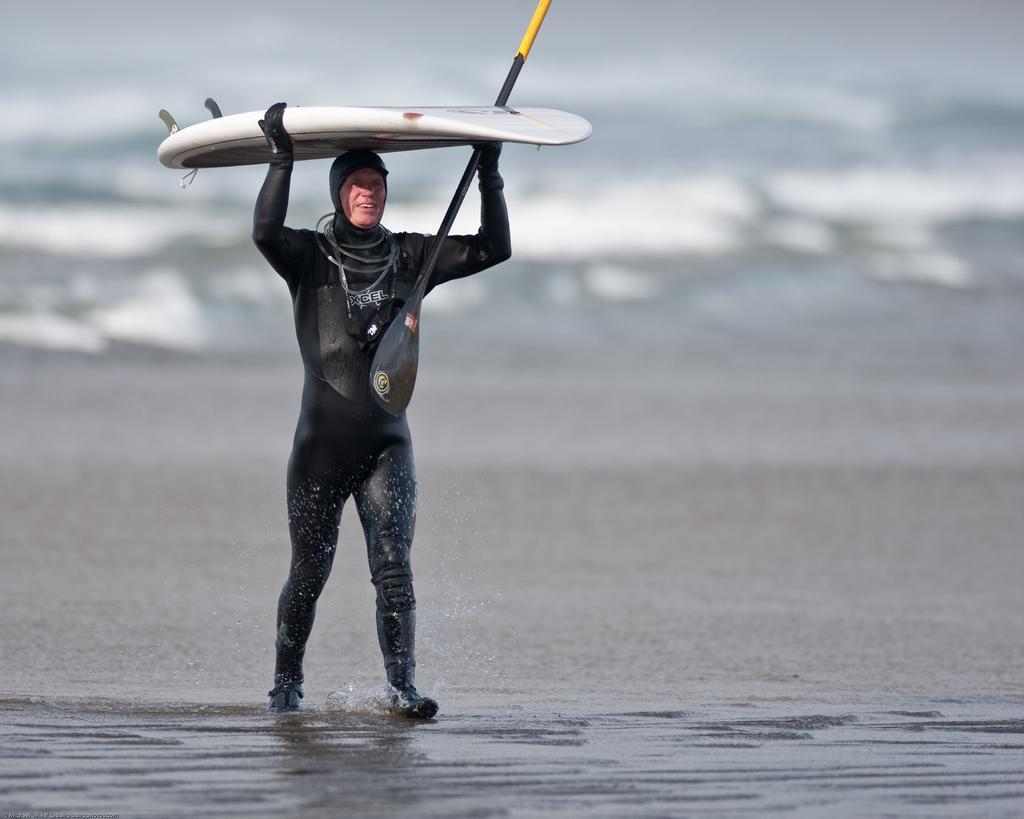In one or two sentences, can you explain what this image depicts? On the left side of the image we can see a man is walking and holding surfing board, stick. In the background of the image we can see the water. At the bottom of the image we can see the sand. 